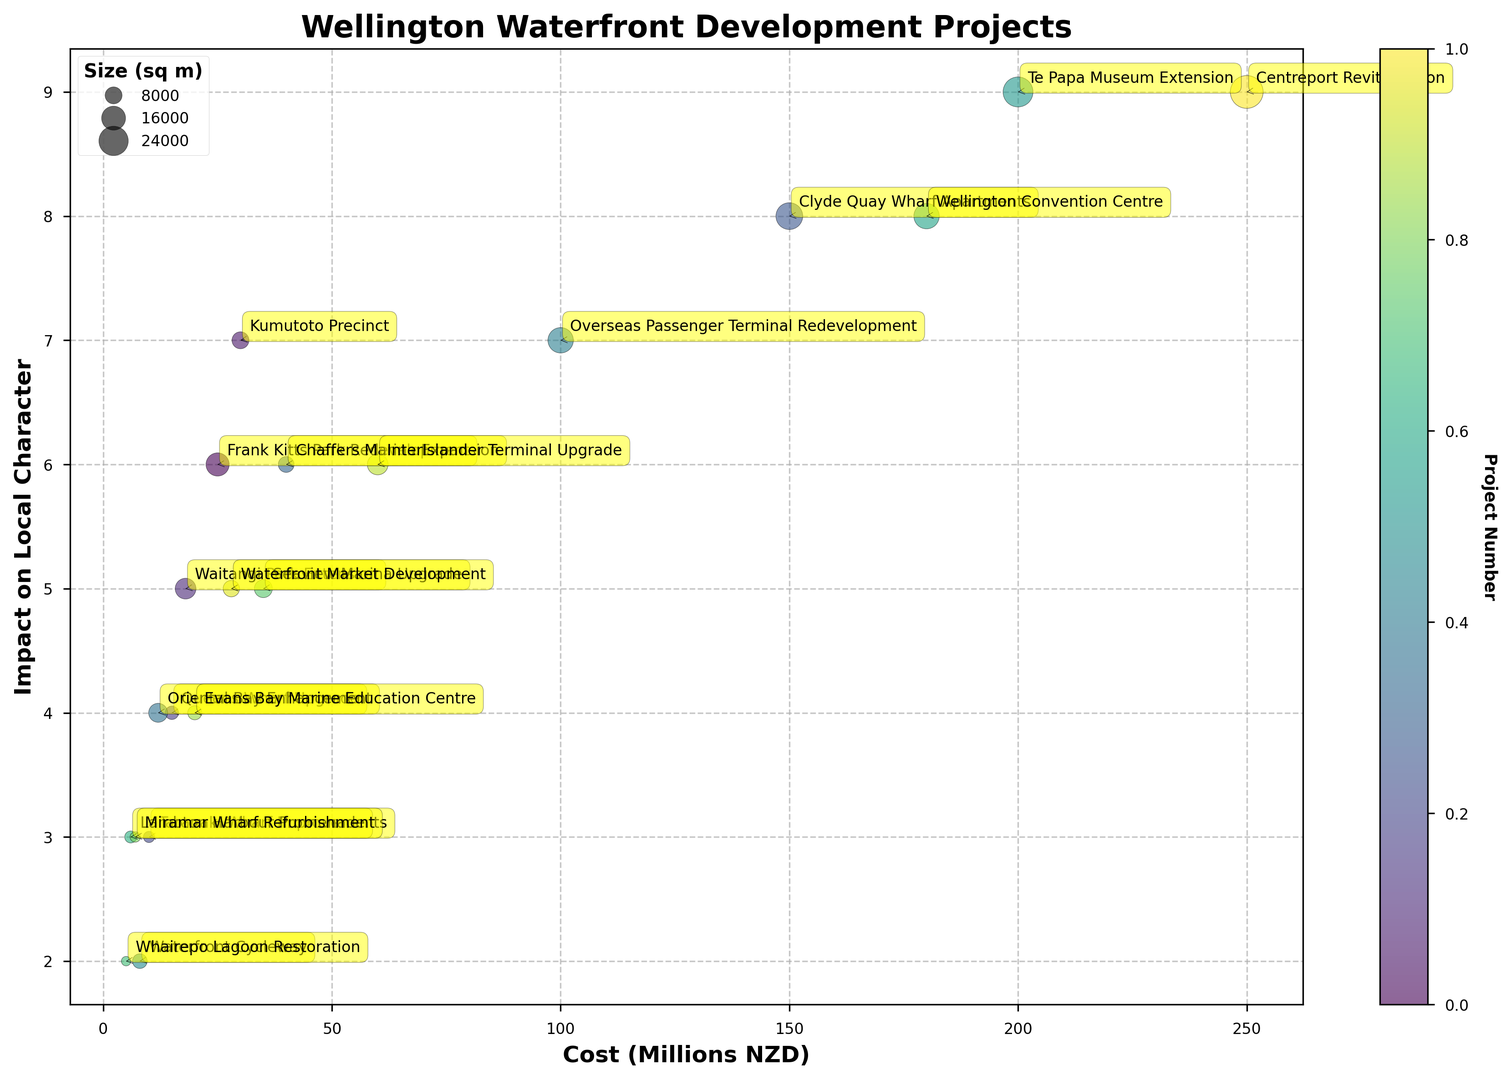What is the project with the highest impact on local character? Look for the project with the highest value on the y-axis representing Impact Score. The Te Papa Museum Extension and Centreport Revitalization both have an Impact Score of 9.
Answer: Te Papa Museum Extension, Centreport Revitalization Which project has the largest size in square meters? Observe the size of the bubbles, which represent the Size in square meters. The largest bubble corresponds to the Centreport Revitalization project.
Answer: Centreport Revitalization What is the total impact score of projects that cost more than 100 million NZD? Identify projects costing more than 100 million NZD: Clyde Quay Wharf Apartments (150 million), Te Papa Museum Extension (200 million), Wellington Convention Centre (180 million), and Centreport Revitalization (250 million). Their Impact Scores are 8, 9, 8, and 9, respectively. Sum these: 8 + 9 + 8 + 9 = 34.
Answer: 34 Which two projects are the closest in terms of cost but have different impact scores? Look for projects with close x-axis (Cost) values but different y-axis (Impact Score) values. The Overseas Passenger Terminal Redevelopment (100 million, Impact Score 7) and Clyde Quay Wharf Apartments (150 million, Impact Score 8) fit this criterion.
Answer: Overseas Passenger Terminal Redevelopment and Clyde Quay Wharf Apartments Identify the project with the smallest size and its impact score. Look for the smallest bubble representing the size. The Whairepo Lagoon Restoration is the smallest with 2,500 sqm. Its Impact Score is 2.
Answer: Whairepo Lagoon Restoration, 2 Which project has a moderate cost and moderate impact score, and how does its size compare to others? “Moderate” is subjective but can be defined by mid-range values. The Kumutoto Precinct (30 million, Impact Score 7) fits this. Its size (8,000 sqm) is smaller than Centreport Revitalization and Te Papa Museum Extension, but larger than Queens Wharf Upgrade and Taranaki Wharf Improvements.
Answer: Kumutoto Precinct, moderate How does the cost of the project with the smallest impact score compare to the project with the highest impact score? The Waterfront Cycleway has the smallest Impact Score (2) with a cost of 8 million. The Te Papa Museum Extension and Centreport Revitalization both have the highest Impact Score (9) and cost 200 million and 250 million, respectively.
Answer: 8 million vs. 200 million and 250 million 